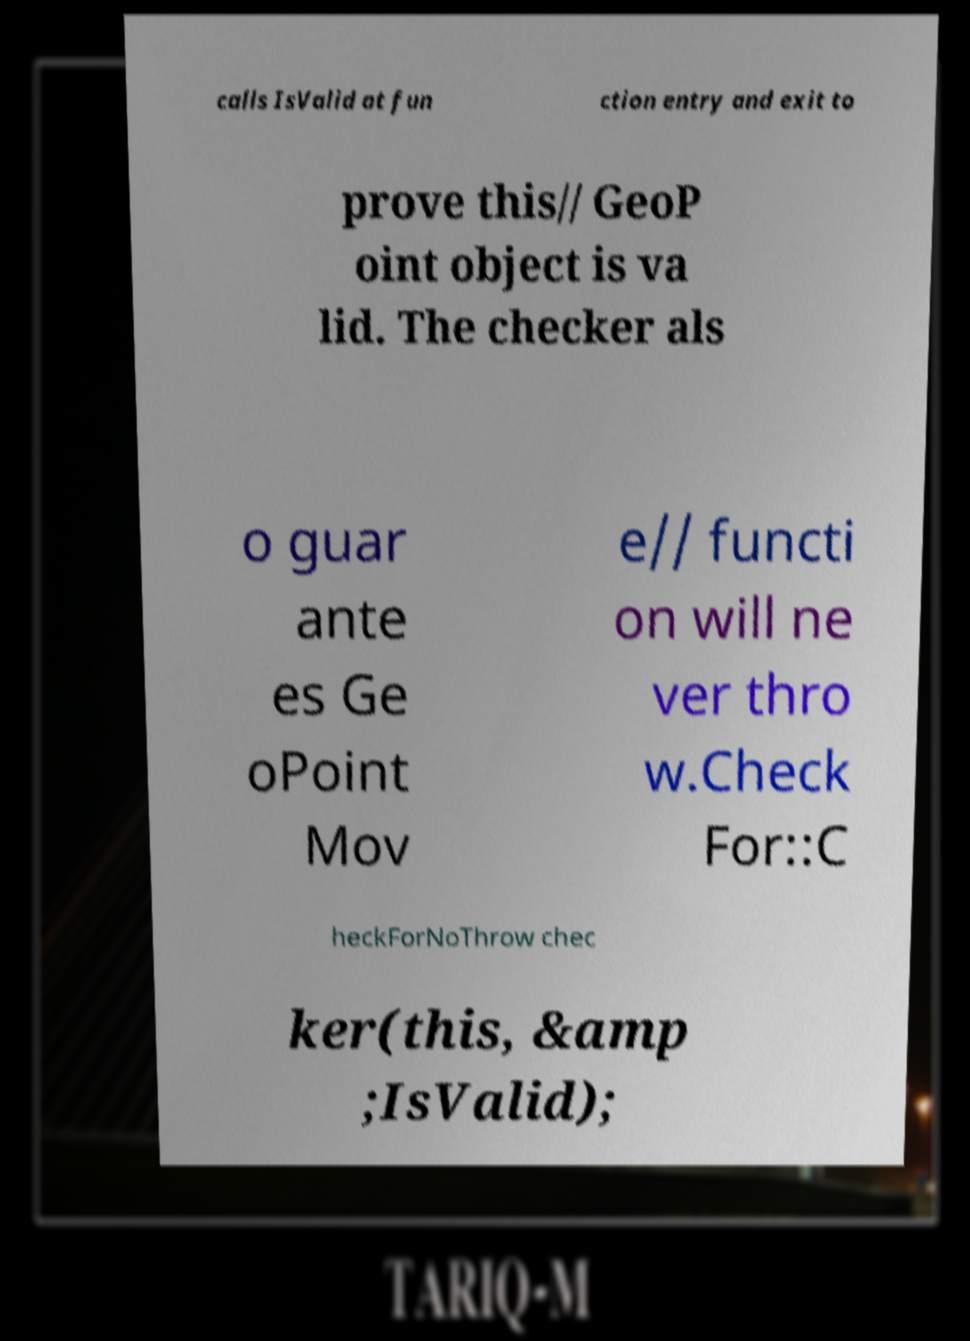Please identify and transcribe the text found in this image. calls IsValid at fun ction entry and exit to prove this// GeoP oint object is va lid. The checker als o guar ante es Ge oPoint Mov e// functi on will ne ver thro w.Check For::C heckForNoThrow chec ker(this, &amp ;IsValid); 